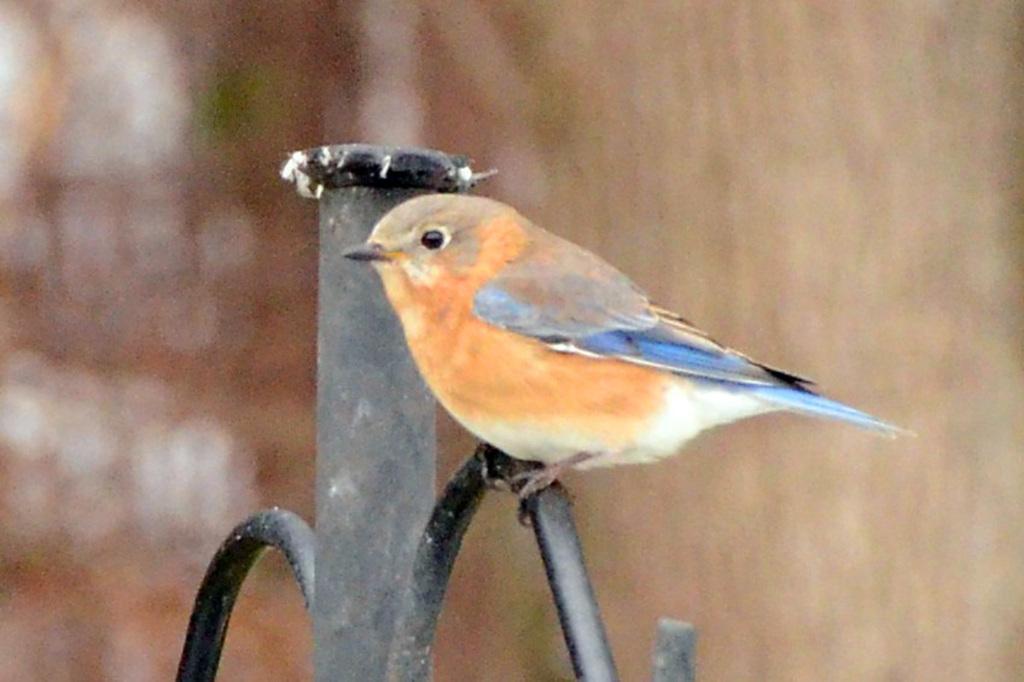Can you describe this image briefly? In this image we can see a bird on a metal stand. 